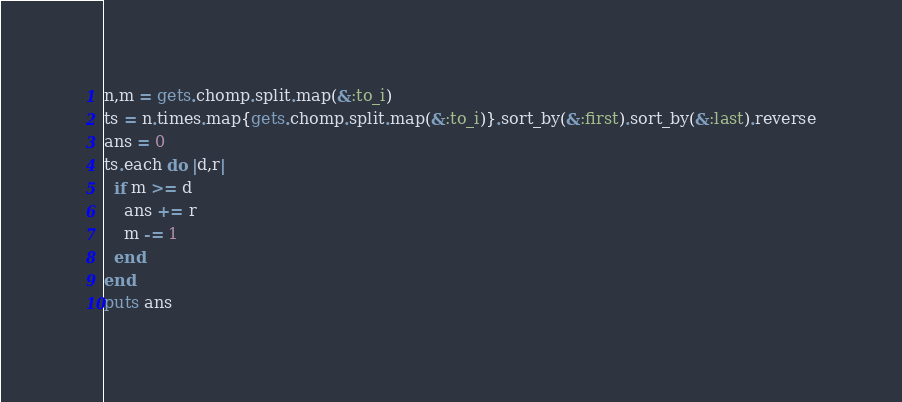<code> <loc_0><loc_0><loc_500><loc_500><_Ruby_>n,m = gets.chomp.split.map(&:to_i)
ts = n.times.map{gets.chomp.split.map(&:to_i)}.sort_by(&:first).sort_by(&:last).reverse
ans = 0
ts.each do |d,r|
  if m >= d
    ans += r
    m -= 1
  end
end
puts ans</code> 